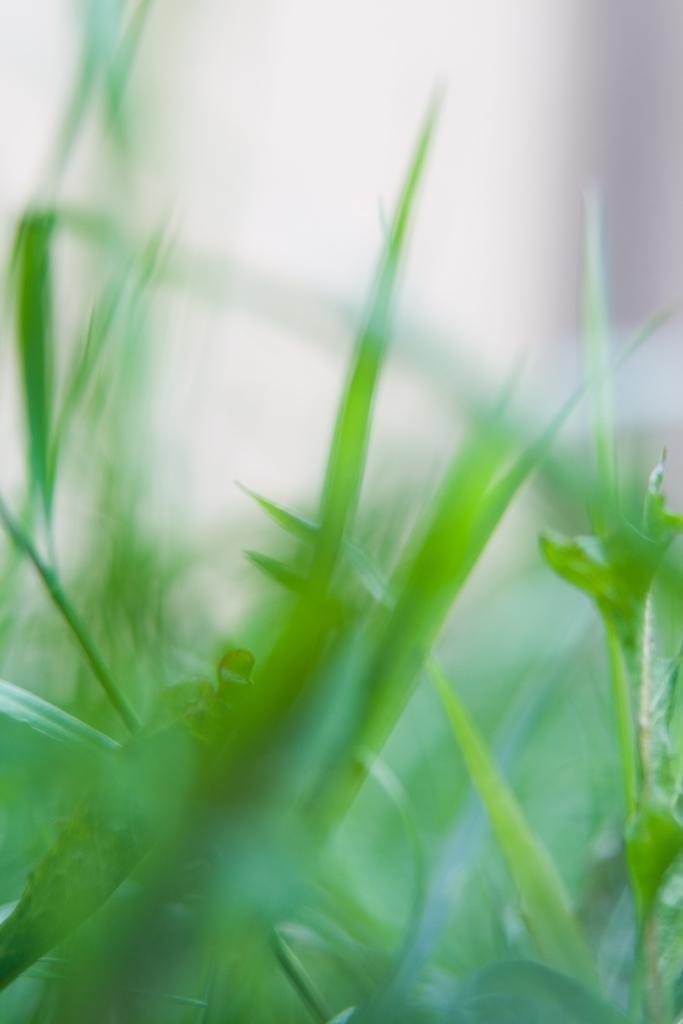Describe this image in one or two sentences. In this image we can see some plants and the background is blurred. 